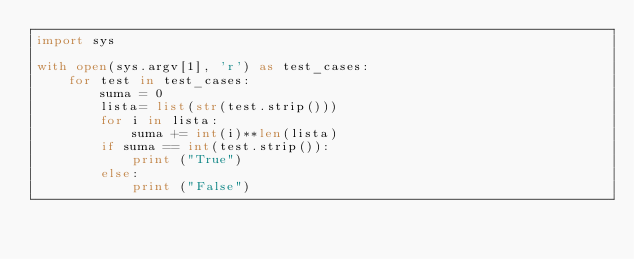Convert code to text. <code><loc_0><loc_0><loc_500><loc_500><_Python_>import sys

with open(sys.argv[1], 'r') as test_cases:
    for test in test_cases:
        suma = 0
        lista= list(str(test.strip()))
        for i in lista:
            suma += int(i)**len(lista)
        if suma == int(test.strip()):
            print ("True") 
        else:
            print ("False")</code> 